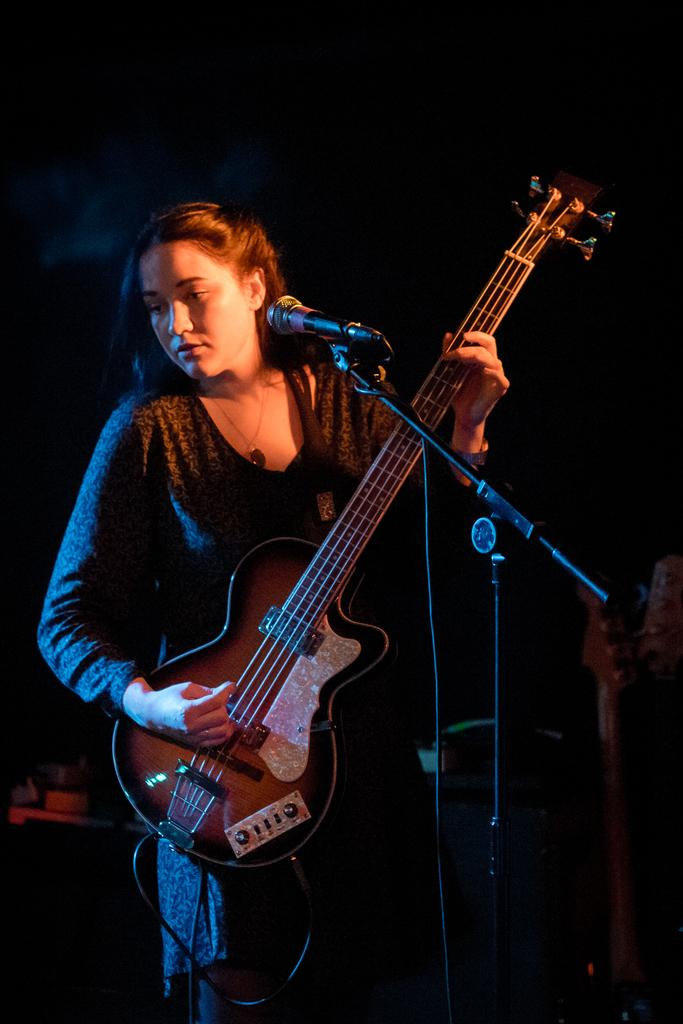Who is the main subject in the image? There is a woman in the image. What is the woman doing in the image? The woman is standing in the image. What object is the woman holding? The woman is holding a guitar in the image. What device is present in front of the woman? A microphone is present in front of the woman in the image. What type of curve can be seen on the cat's back in the image? There is no cat present in the image, so it is not possible to observe any curves on its back. 